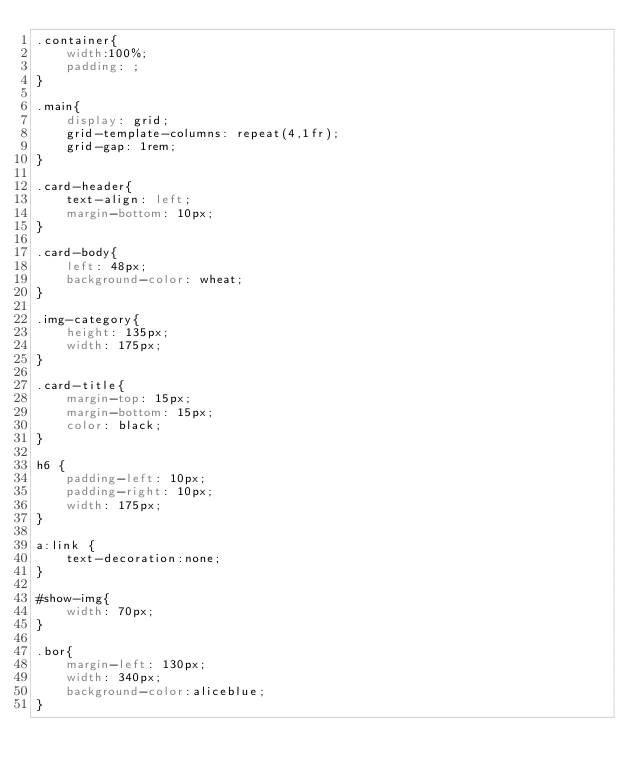Convert code to text. <code><loc_0><loc_0><loc_500><loc_500><_CSS_>.container{
    width:100%;
    padding: ;
}

.main{
    display: grid;
    grid-template-columns: repeat(4,1fr);
    grid-gap: 1rem;
}

.card-header{
    text-align: left;
    margin-bottom: 10px;
}

.card-body{
    left: 48px;
    background-color: wheat;
}

.img-category{
    height: 135px;
    width: 175px;
}

.card-title{
    margin-top: 15px;
    margin-bottom: 15px;
    color: black;
}

h6 {
    padding-left: 10px;
    padding-right: 10px;
    width: 175px;
}

a:link {
    text-decoration:none;
}

#show-img{
    width: 70px;
}

.bor{
    margin-left: 130px;
    width: 340px;
    background-color:aliceblue;
}


</code> 